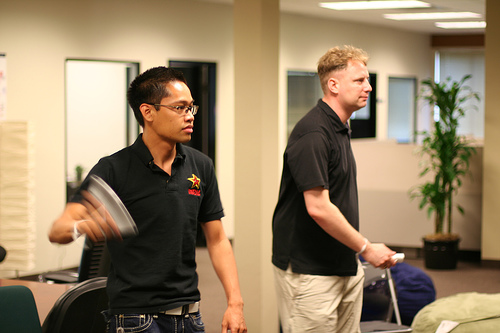What color is the luggage? The luggage displayed in the scene is purple, providing a bright pop of color in the room's decor. 